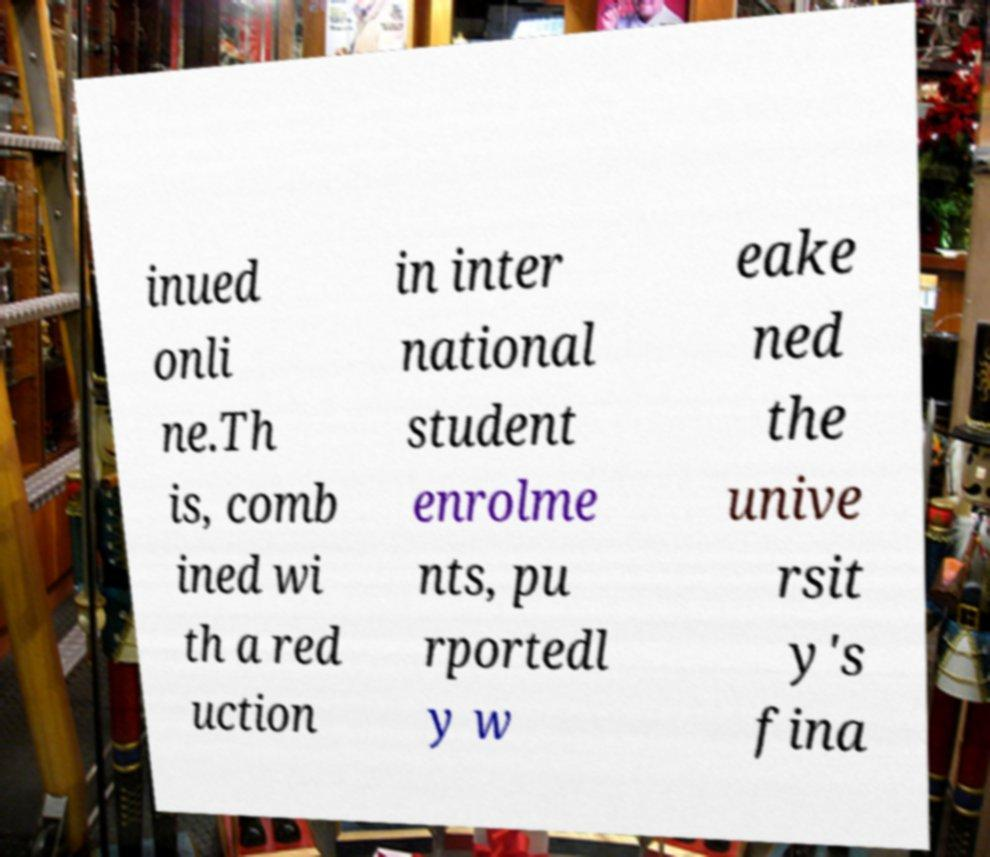There's text embedded in this image that I need extracted. Can you transcribe it verbatim? inued onli ne.Th is, comb ined wi th a red uction in inter national student enrolme nts, pu rportedl y w eake ned the unive rsit y's fina 